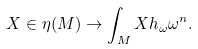Convert formula to latex. <formula><loc_0><loc_0><loc_500><loc_500>X \in \eta ( M ) \rightarrow \int _ { M } X h _ { \omega } \omega ^ { n } .</formula> 